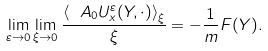Convert formula to latex. <formula><loc_0><loc_0><loc_500><loc_500>\lim _ { \varepsilon \to 0 } \lim _ { \xi \to 0 } \frac { \left \langle \ A _ { 0 } U _ { x } ^ { \varepsilon } ( Y , \cdot ) \right \rangle _ { \xi } } { \xi } = - \frac { 1 } { m } F ( Y ) .</formula> 